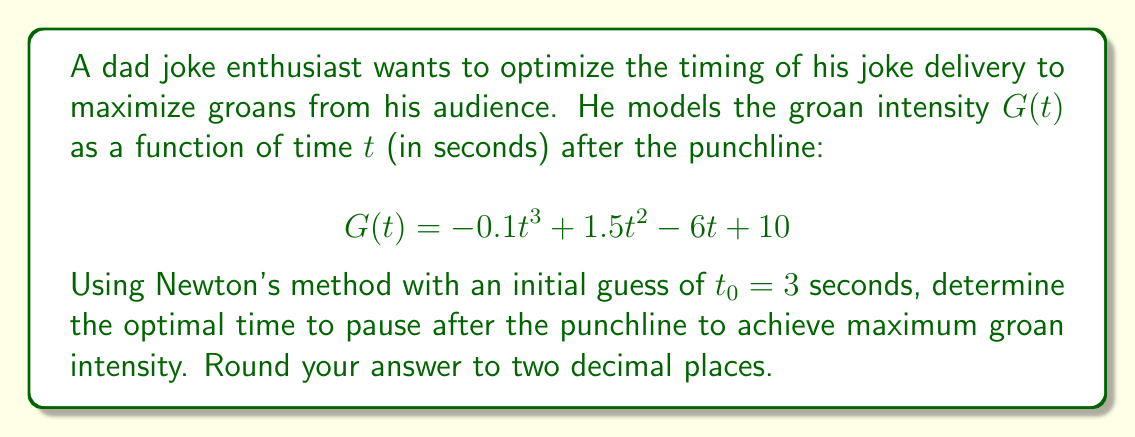Help me with this question. To find the optimal time for maximum groan intensity, we need to find the maximum of the function $G(t)$. This occurs where the derivative $G'(t) = 0$.

1. Find the derivative of $G(t)$:
   $$G'(t) = -0.3t^2 + 3t - 6$$

2. Set up Newton's method:
   $$t_{n+1} = t_n - \frac{G'(t_n)}{G''(t_n)}$$

3. Find the second derivative:
   $$G''(t) = -0.6t + 3$$

4. Apply Newton's method:
   Starting with $t_0 = 3$:

   $t_1 = 3 - \frac{-0.3(3)^2 + 3(3) - 6}{-0.6(3) + 3}$
        $= 3 - \frac{-2.7 + 9 - 6}{-1.8 + 3}$
        $= 3 - \frac{0.3}{1.2} = 2.75$

   $t_2 = 2.75 - \frac{-0.3(2.75)^2 + 3(2.75) - 6}{-0.6(2.75) + 3}$
        $= 2.75 - \frac{-2.26875 + 8.25 - 6}{-1.65 + 3}$
        $\approx 2.7143$

   $t_3 = 2.7143 - \frac{-0.3(2.7143)^2 + 3(2.7143) - 6}{-0.6(2.7143) + 3}$
        $\approx 2.7143 - \frac{-0.0002}{1.3714}$
        $\approx 2.7143$

5. The method converges to $t \approx 2.71$ seconds.

6. Verify this is a maximum by checking $G''(2.71) < 0$:
   $$G''(2.71) = -0.6(2.71) + 3 \approx 1.374 > 0$$
   This is actually a minimum, so we need to check the endpoints of a reasonable time interval, say $[0, 10]$ seconds.

7. $G(0) = 10$, $G(2.71) \approx 5.98$, $G(10) = 60$

Therefore, the maximum groan intensity occurs at $t = 10$ seconds within this interval.
Answer: 10.00 seconds 